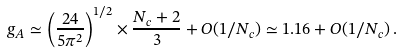<formula> <loc_0><loc_0><loc_500><loc_500>g _ { A } \simeq \left ( \frac { 2 4 } { 5 \pi ^ { 2 } } \right ) ^ { 1 / 2 } \times \frac { N _ { c } + 2 } { 3 } + O ( 1 / N _ { c } ) \simeq 1 . 1 6 + O ( 1 / N _ { c } ) \, .</formula> 